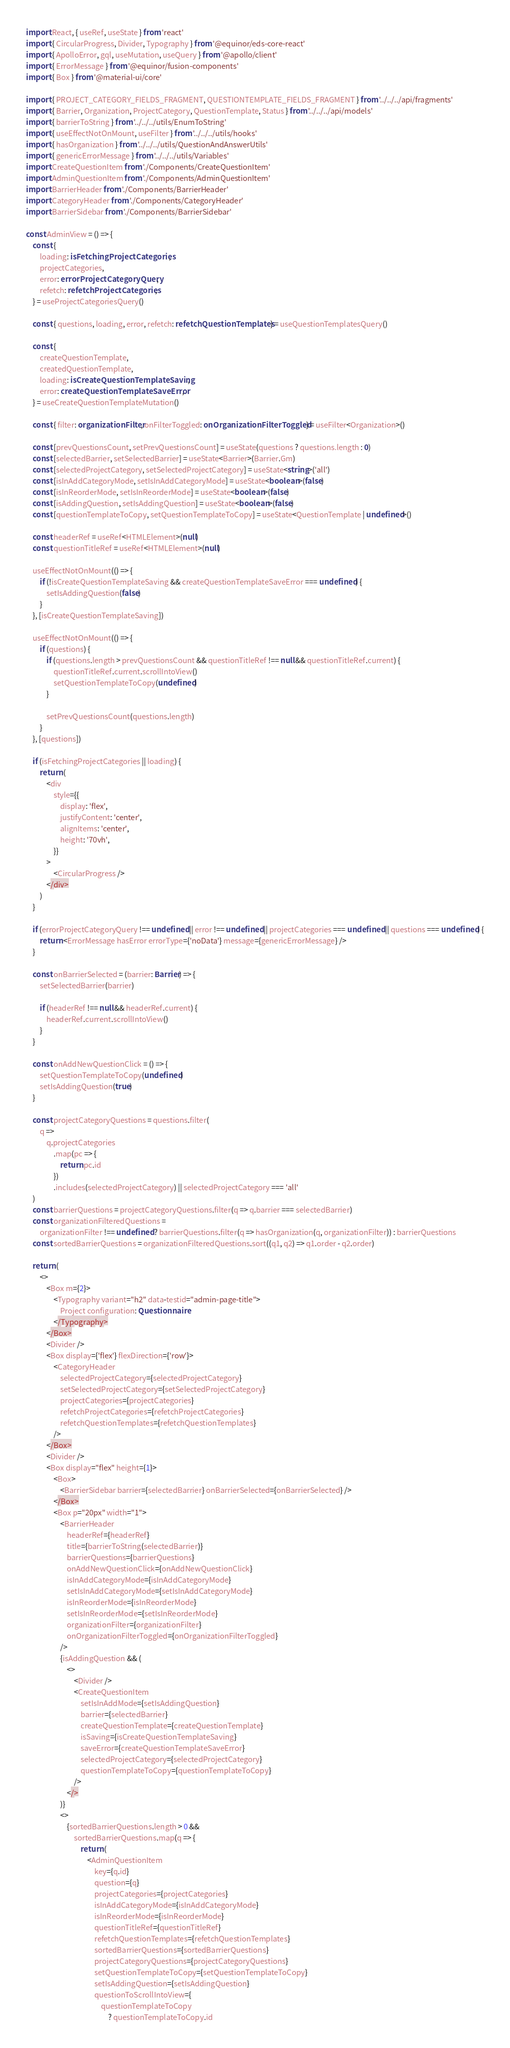<code> <loc_0><loc_0><loc_500><loc_500><_TypeScript_>import React, { useRef, useState } from 'react'
import { CircularProgress, Divider, Typography } from '@equinor/eds-core-react'
import { ApolloError, gql, useMutation, useQuery } from '@apollo/client'
import { ErrorMessage } from '@equinor/fusion-components'
import { Box } from '@material-ui/core'

import { PROJECT_CATEGORY_FIELDS_FRAGMENT, QUESTIONTEMPLATE_FIELDS_FRAGMENT } from '../../../api/fragments'
import { Barrier, Organization, ProjectCategory, QuestionTemplate, Status } from '../../../api/models'
import { barrierToString } from '../../../utils/EnumToString'
import { useEffectNotOnMount, useFilter } from '../../../utils/hooks'
import { hasOrganization } from '../../../utils/QuestionAndAnswerUtils'
import { genericErrorMessage } from '../../../utils/Variables'
import CreateQuestionItem from './Components/CreateQuestionItem'
import AdminQuestionItem from './Components/AdminQuestionItem'
import BarrierHeader from './Components/BarrierHeader'
import CategoryHeader from './Components/CategoryHeader'
import BarrierSidebar from './Components/BarrierSidebar'

const AdminView = () => {
    const {
        loading: isFetchingProjectCategories,
        projectCategories,
        error: errorProjectCategoryQuery,
        refetch: refetchProjectCategories,
    } = useProjectCategoriesQuery()

    const { questions, loading, error, refetch: refetchQuestionTemplates } = useQuestionTemplatesQuery()

    const {
        createQuestionTemplate,
        createdQuestionTemplate,
        loading: isCreateQuestionTemplateSaving,
        error: createQuestionTemplateSaveError,
    } = useCreateQuestionTemplateMutation()

    const { filter: organizationFilter, onFilterToggled: onOrganizationFilterToggled } = useFilter<Organization>()

    const [prevQuestionsCount, setPrevQuestionsCount] = useState(questions ? questions.length : 0)
    const [selectedBarrier, setSelectedBarrier] = useState<Barrier>(Barrier.Gm)
    const [selectedProjectCategory, setSelectedProjectCategory] = useState<string>('all')
    const [isInAddCategoryMode, setIsInAddCategoryMode] = useState<boolean>(false)
    const [isInReorderMode, setIsInReorderMode] = useState<boolean>(false)
    const [isAddingQuestion, setIsAddingQuestion] = useState<boolean>(false)
    const [questionTemplateToCopy, setQuestionTemplateToCopy] = useState<QuestionTemplate | undefined>()

    const headerRef = useRef<HTMLElement>(null)
    const questionTitleRef = useRef<HTMLElement>(null)

    useEffectNotOnMount(() => {
        if (!isCreateQuestionTemplateSaving && createQuestionTemplateSaveError === undefined) {
            setIsAddingQuestion(false)
        }
    }, [isCreateQuestionTemplateSaving])

    useEffectNotOnMount(() => {
        if (questions) {
            if (questions.length > prevQuestionsCount && questionTitleRef !== null && questionTitleRef.current) {
                questionTitleRef.current.scrollIntoView()
                setQuestionTemplateToCopy(undefined)
            }

            setPrevQuestionsCount(questions.length)
        }
    }, [questions])

    if (isFetchingProjectCategories || loading) {
        return (
            <div
                style={{
                    display: 'flex',
                    justifyContent: 'center',
                    alignItems: 'center',
                    height: '70vh',
                }}
            >
                <CircularProgress />
            </div>
        )
    }

    if (errorProjectCategoryQuery !== undefined || error !== undefined || projectCategories === undefined || questions === undefined) {
        return <ErrorMessage hasError errorType={'noData'} message={genericErrorMessage} />
    }

    const onBarrierSelected = (barrier: Barrier) => {
        setSelectedBarrier(barrier)

        if (headerRef !== null && headerRef.current) {
            headerRef.current.scrollIntoView()
        }
    }

    const onAddNewQuestionClick = () => {
        setQuestionTemplateToCopy(undefined)
        setIsAddingQuestion(true)
    }

    const projectCategoryQuestions = questions.filter(
        q =>
            q.projectCategories
                .map(pc => {
                    return pc.id
                })
                .includes(selectedProjectCategory) || selectedProjectCategory === 'all'
    )
    const barrierQuestions = projectCategoryQuestions.filter(q => q.barrier === selectedBarrier)
    const organizationFilteredQuestions =
        organizationFilter !== undefined ? barrierQuestions.filter(q => hasOrganization(q, organizationFilter)) : barrierQuestions
    const sortedBarrierQuestions = organizationFilteredQuestions.sort((q1, q2) => q1.order - q2.order)

    return (
        <>
            <Box m={2}>
                <Typography variant="h2" data-testid="admin-page-title">
                    Project configuration: Questionnaire
                </Typography>
            </Box>
            <Divider />
            <Box display={'flex'} flexDirection={'row'}>
                <CategoryHeader
                    selectedProjectCategory={selectedProjectCategory}
                    setSelectedProjectCategory={setSelectedProjectCategory}
                    projectCategories={projectCategories}
                    refetchProjectCategories={refetchProjectCategories}
                    refetchQuestionTemplates={refetchQuestionTemplates}
                />
            </Box>
            <Divider />
            <Box display="flex" height={1}>
                <Box>
                    <BarrierSidebar barrier={selectedBarrier} onBarrierSelected={onBarrierSelected} />
                </Box>
                <Box p="20px" width="1">
                    <BarrierHeader
                        headerRef={headerRef}
                        title={barrierToString(selectedBarrier)}
                        barrierQuestions={barrierQuestions}
                        onAddNewQuestionClick={onAddNewQuestionClick}
                        isInAddCategoryMode={isInAddCategoryMode}
                        setIsInAddCategoryMode={setIsInAddCategoryMode}
                        isInReorderMode={isInReorderMode}
                        setIsInReorderMode={setIsInReorderMode}
                        organizationFilter={organizationFilter}
                        onOrganizationFilterToggled={onOrganizationFilterToggled}
                    />
                    {isAddingQuestion && (
                        <>
                            <Divider />
                            <CreateQuestionItem
                                setIsInAddMode={setIsAddingQuestion}
                                barrier={selectedBarrier}
                                createQuestionTemplate={createQuestionTemplate}
                                isSaving={isCreateQuestionTemplateSaving}
                                saveError={createQuestionTemplateSaveError}
                                selectedProjectCategory={selectedProjectCategory}
                                questionTemplateToCopy={questionTemplateToCopy}
                            />
                        </>
                    )}
                    <>
                        {sortedBarrierQuestions.length > 0 &&
                            sortedBarrierQuestions.map(q => {
                                return (
                                    <AdminQuestionItem
                                        key={q.id}
                                        question={q}
                                        projectCategories={projectCategories}
                                        isInAddCategoryMode={isInAddCategoryMode}
                                        isInReorderMode={isInReorderMode}
                                        questionTitleRef={questionTitleRef}
                                        refetchQuestionTemplates={refetchQuestionTemplates}
                                        sortedBarrierQuestions={sortedBarrierQuestions}
                                        projectCategoryQuestions={projectCategoryQuestions}
                                        setQuestionTemplateToCopy={setQuestionTemplateToCopy}
                                        setIsAddingQuestion={setIsAddingQuestion}
                                        questionToScrollIntoView={
                                            questionTemplateToCopy
                                                ? questionTemplateToCopy.id</code> 